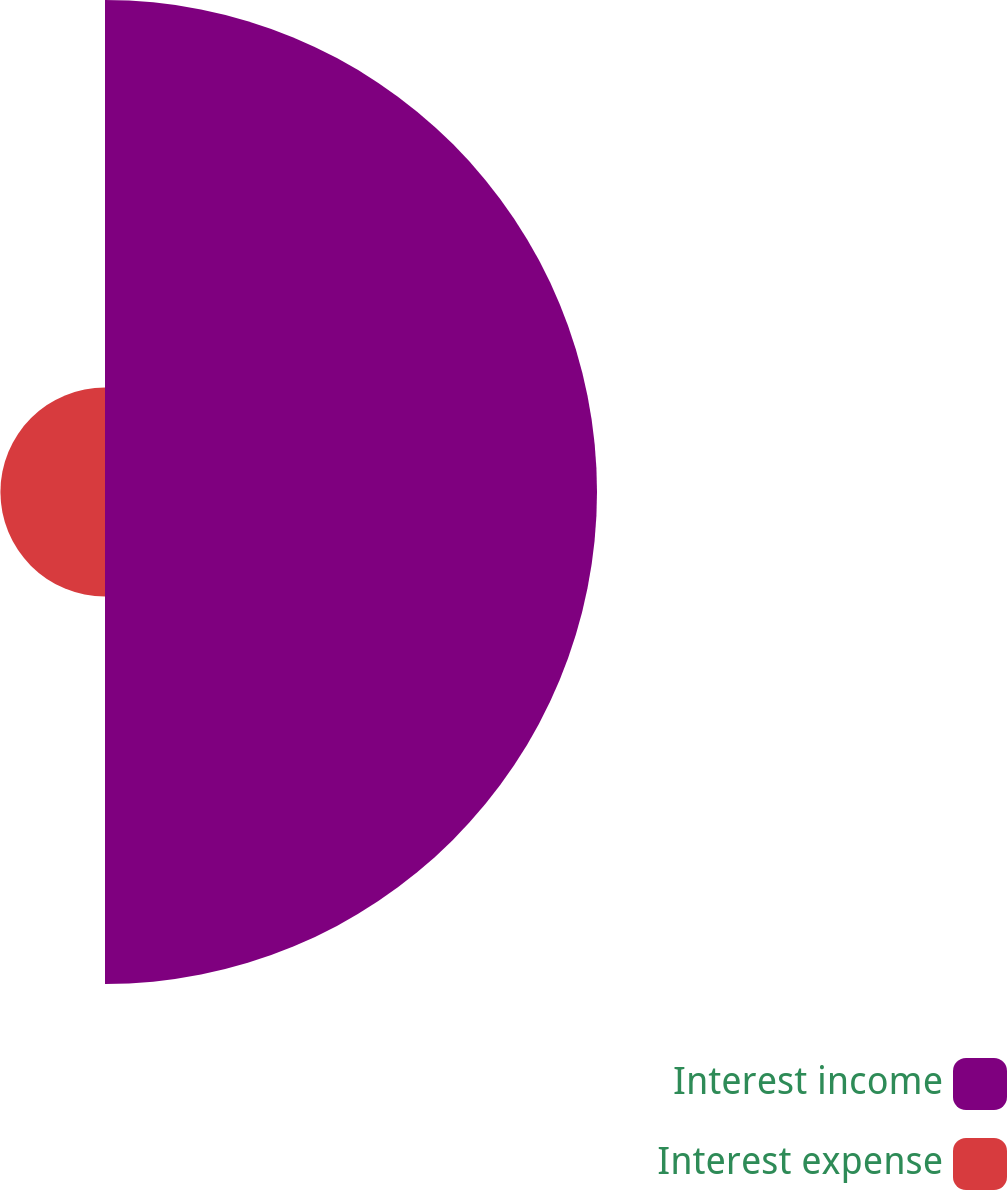<chart> <loc_0><loc_0><loc_500><loc_500><pie_chart><fcel>Interest income<fcel>Interest expense<nl><fcel>82.47%<fcel>17.53%<nl></chart> 